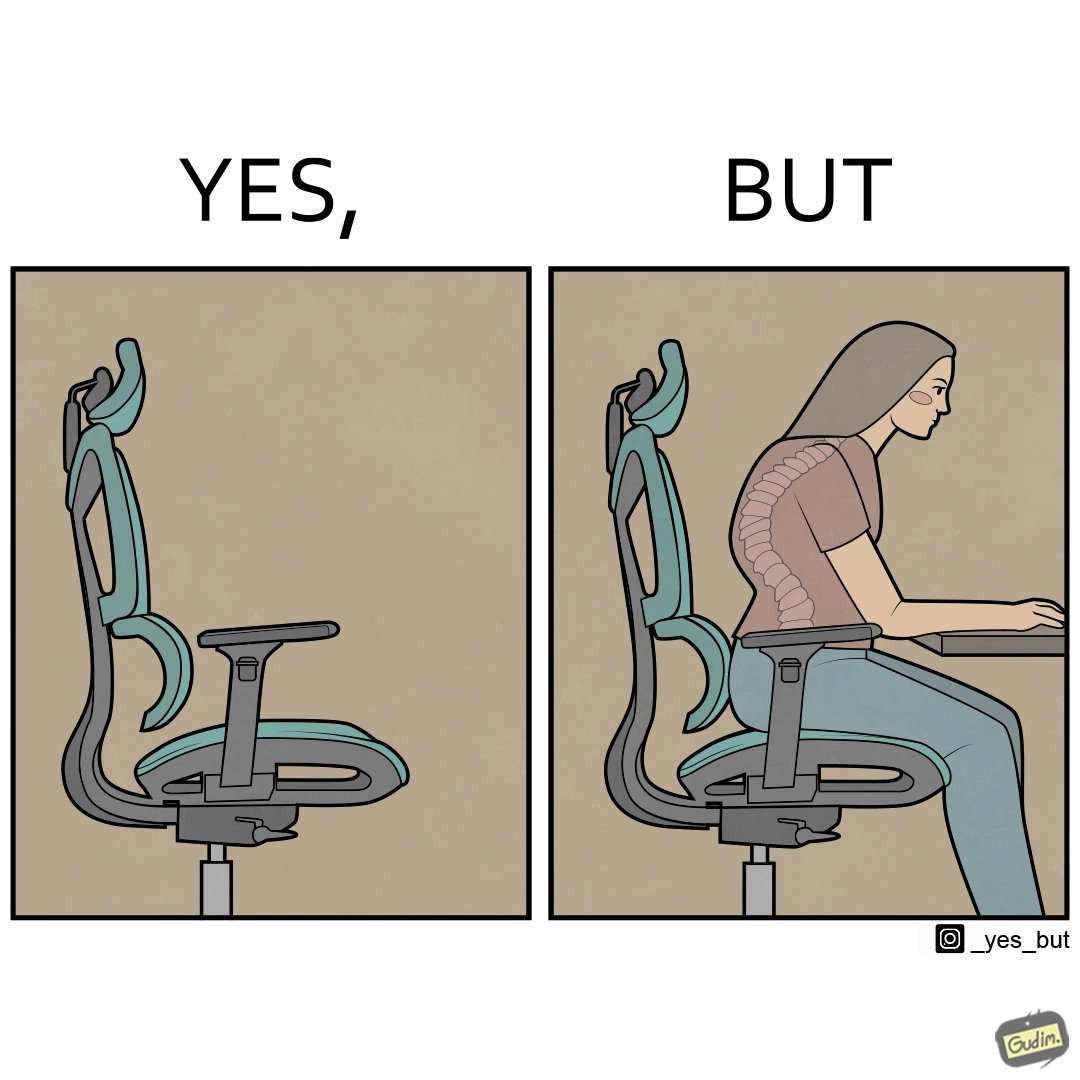Describe what you see in the left and right parts of this image. In the left part of the image: an ergonomic chair. In the right part of the image: a person sitting on a ergonomic chair with a bent spine. 